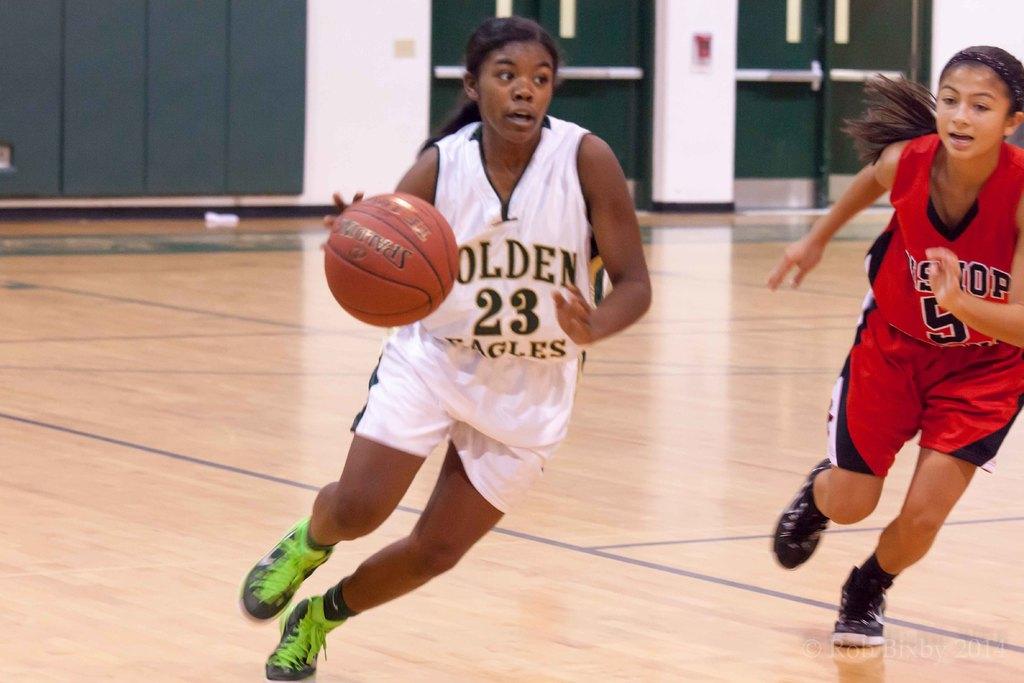What team is the person with the ball on?
Provide a short and direct response. Golden eagles. 